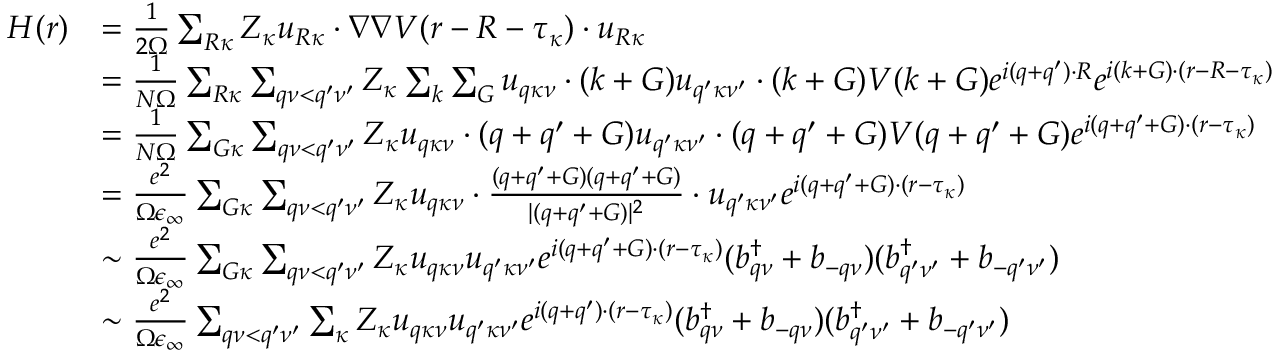Convert formula to latex. <formula><loc_0><loc_0><loc_500><loc_500>\begin{array} { r l } { H ( r ) } & { = \frac { 1 } { 2 \Omega } \sum _ { R \kappa } Z _ { \kappa } u _ { R \kappa } \cdot \nabla \nabla V ( r - R - \tau _ { \kappa } ) \cdot u _ { R \kappa } } \\ & { = \frac { 1 } { N \Omega } \sum _ { R \kappa } \sum _ { q \nu < q ^ { \prime } \nu ^ { \prime } } Z _ { \kappa } \sum _ { k } \sum _ { G } u _ { q \kappa \nu } \cdot ( k + G ) u _ { q ^ { \prime } \kappa \nu ^ { \prime } } \cdot ( k + G ) V ( k + G ) e ^ { i ( q + q ^ { \prime } ) \cdot R } e ^ { i ( k + G ) \cdot ( r - R - \tau _ { \kappa } ) } } \\ & { = \frac { 1 } { N \Omega } \sum _ { G \kappa } \sum _ { q \nu < q ^ { \prime } \nu ^ { \prime } } Z _ { \kappa } u _ { q \kappa \nu } \cdot ( q + q ^ { \prime } + G ) u _ { q ^ { \prime } \kappa \nu ^ { \prime } } \cdot ( q + q ^ { \prime } + G ) V ( q + q ^ { \prime } + G ) e ^ { i ( q + q ^ { \prime } + G ) \cdot ( r - \tau _ { \kappa } ) } } \\ & { = \frac { e ^ { 2 } } { \Omega \epsilon _ { \infty } } \sum _ { G \kappa } \sum _ { q \nu < q ^ { \prime } \nu ^ { \prime } } Z _ { \kappa } u _ { q \kappa \nu } \cdot \frac { ( q + q ^ { \prime } + G ) ( q + q ^ { \prime } + G ) } { | ( q + q ^ { \prime } + G ) | ^ { 2 } } \cdot u _ { q ^ { \prime } \kappa \nu ^ { \prime } } e ^ { i ( q + q ^ { \prime } + G ) \cdot ( r - \tau _ { \kappa } ) } } \\ & { \sim \frac { e ^ { 2 } } { \Omega \epsilon _ { \infty } } \sum _ { G \kappa } \sum _ { q \nu < q ^ { \prime } \nu ^ { \prime } } Z _ { \kappa } u _ { q \kappa \nu } u _ { q ^ { \prime } \kappa \nu ^ { \prime } } e ^ { i ( q + q ^ { \prime } + G ) \cdot ( r - \tau _ { \kappa } ) } ( b _ { q \nu } ^ { \dagger } + b _ { - q \nu } ) ( b _ { q ^ { \prime } \nu ^ { \prime } } ^ { \dagger } + b _ { - q ^ { \prime } \nu ^ { \prime } } ) } \\ & { \sim \frac { e ^ { 2 } } { \Omega \epsilon _ { \infty } } \sum _ { q \nu < q ^ { \prime } \nu ^ { \prime } } \sum _ { \kappa } Z _ { \kappa } u _ { q \kappa \nu } u _ { q ^ { \prime } \kappa \nu ^ { \prime } } e ^ { i ( q + q ^ { \prime } ) \cdot ( r - \tau _ { \kappa } ) } ( b _ { q \nu } ^ { \dagger } + b _ { - q \nu } ) ( b _ { q ^ { \prime } \nu ^ { \prime } } ^ { \dagger } + b _ { - q ^ { \prime } \nu ^ { \prime } } ) } \end{array}</formula> 